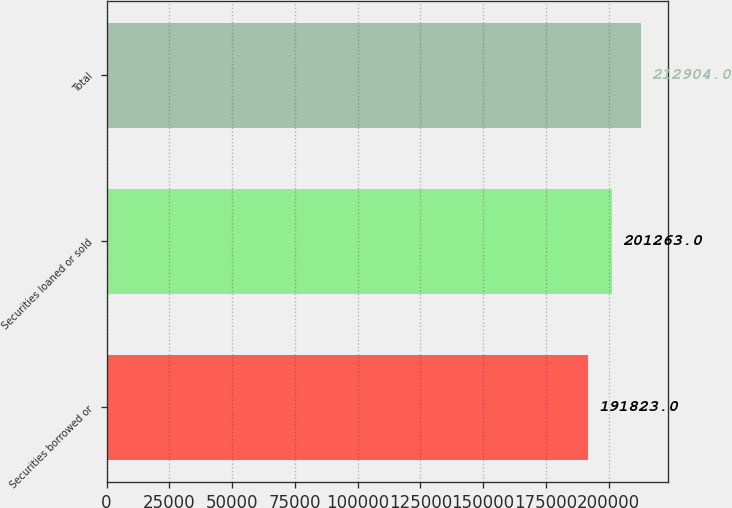Convert chart to OTSL. <chart><loc_0><loc_0><loc_500><loc_500><bar_chart><fcel>Securities borrowed or<fcel>Securities loaned or sold<fcel>Total<nl><fcel>191823<fcel>201263<fcel>212904<nl></chart> 